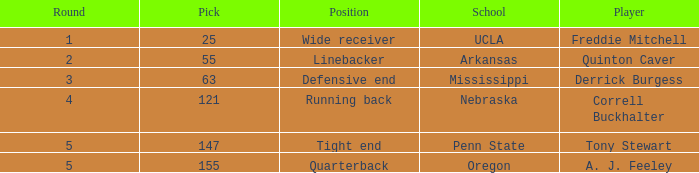Who was the player who was pick number 147? Tony Stewart. 